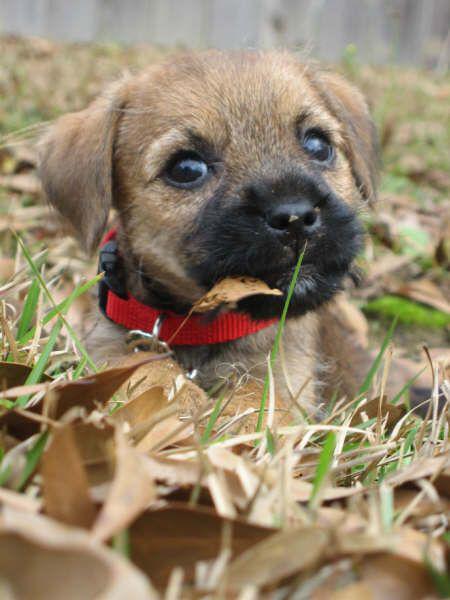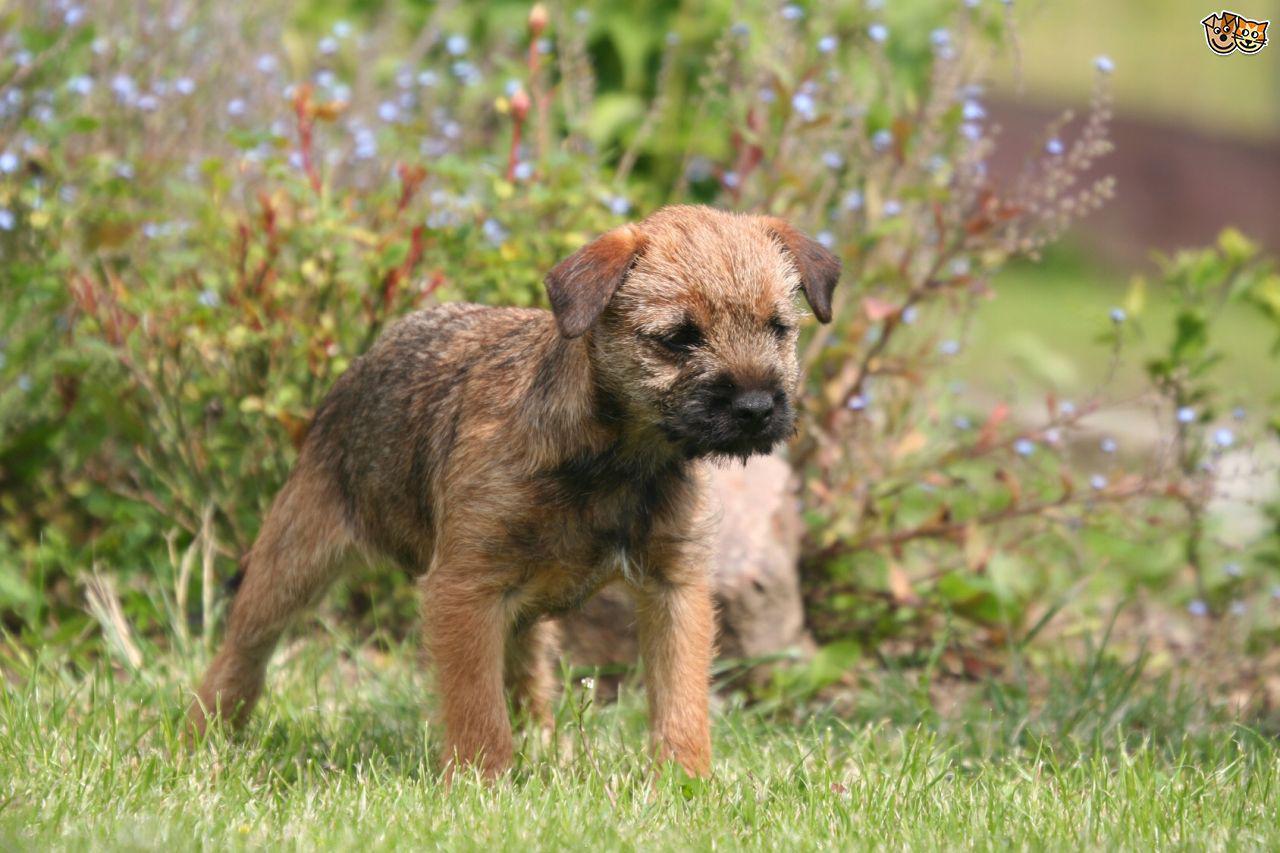The first image is the image on the left, the second image is the image on the right. For the images displayed, is the sentence "At least one dog is wearing a red collar and looking forward." factually correct? Answer yes or no. Yes. 